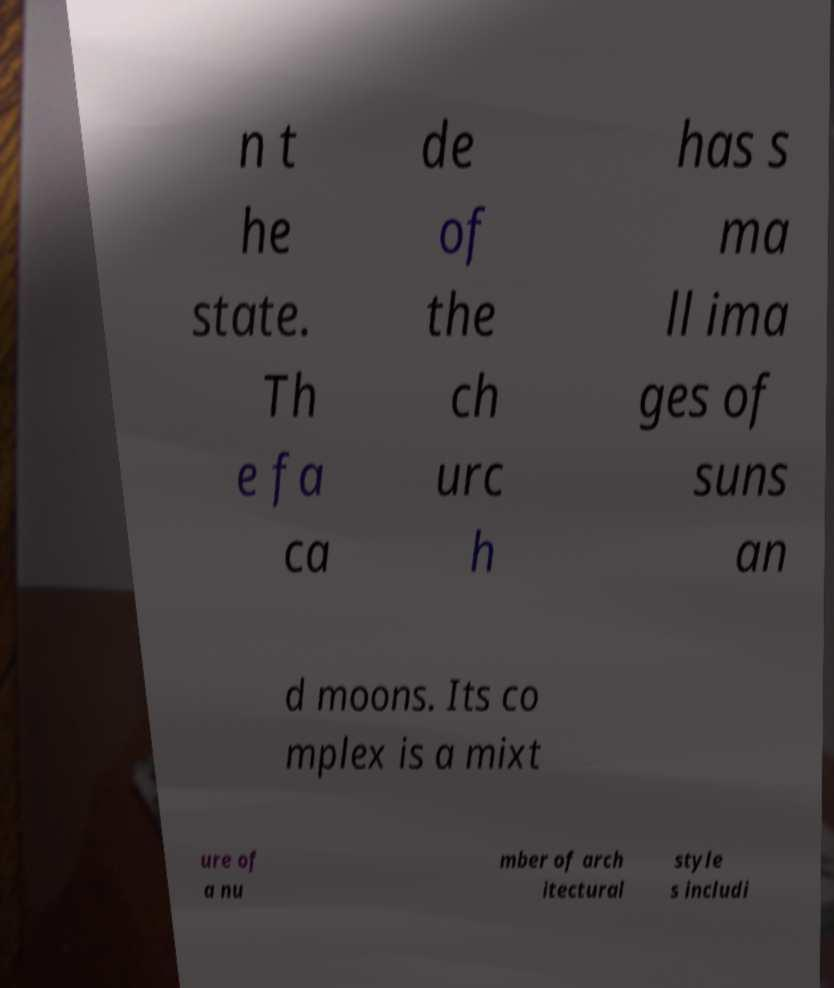I need the written content from this picture converted into text. Can you do that? n t he state. Th e fa ca de of the ch urc h has s ma ll ima ges of suns an d moons. Its co mplex is a mixt ure of a nu mber of arch itectural style s includi 